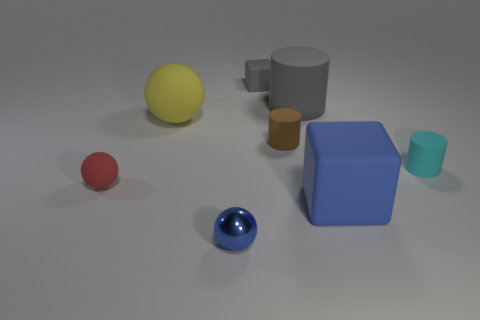The cyan matte object is what size?
Provide a short and direct response. Small. Are there any red balls made of the same material as the cyan cylinder?
Offer a terse response. Yes. What is the size of the gray object that is the same shape as the small brown rubber object?
Give a very brief answer. Large. Are there the same number of blue rubber things that are to the left of the big blue matte thing and small red rubber blocks?
Provide a short and direct response. Yes. There is a tiny thing that is on the right side of the blue rubber block; is it the same shape as the brown rubber thing?
Your answer should be very brief. Yes. What is the shape of the big blue object?
Make the answer very short. Cube. There is a blue object that is to the left of the matte block in front of the gray thing on the right side of the small gray rubber cube; what is it made of?
Make the answer very short. Metal. There is a large cylinder that is the same color as the tiny block; what material is it?
Provide a succinct answer. Rubber. What number of objects are either small cyan matte cylinders or brown blocks?
Your response must be concise. 1. Do the tiny sphere that is behind the tiny blue metal object and the cyan thing have the same material?
Offer a very short reply. Yes. 